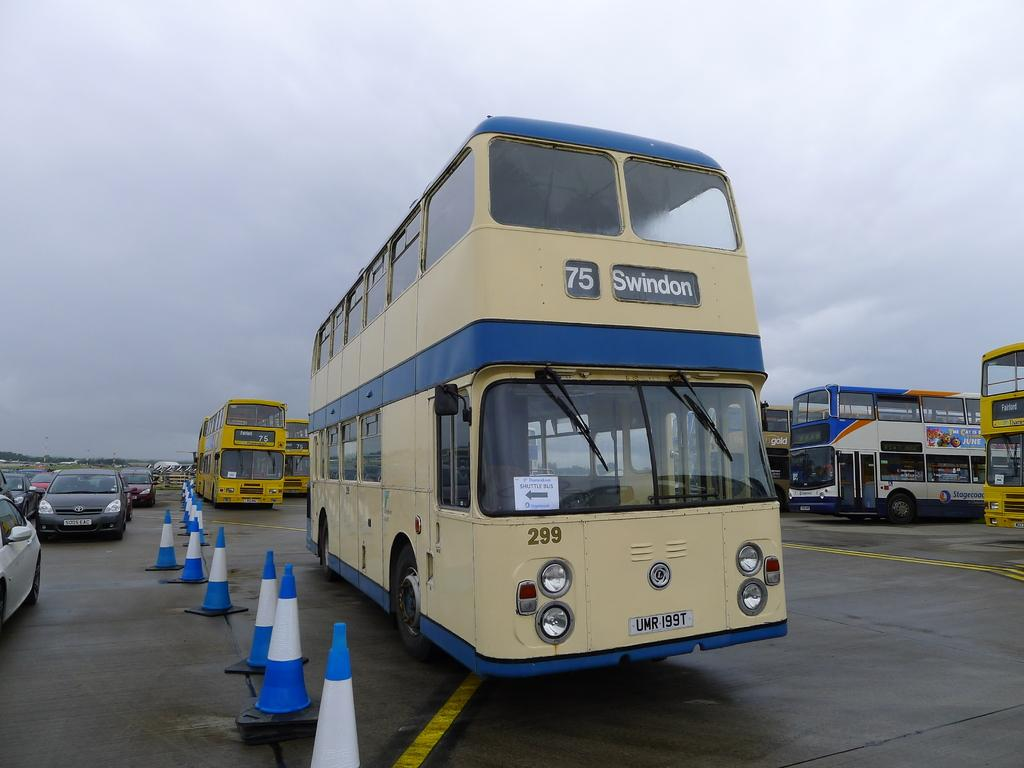What is happening on the road in the image? There are vehicles on the road in the image. Can you describe any specific details about the vehicles? Text is visible on some of the vehicles. What else is present beside the vehicles on the road? Barriers are present beside the vehicles. What is visible at the top of the image? The sky is visible at the top of the image. How many rabbits are sitting on the vehicles in the image? There are no rabbits present in the image; it features vehicles on the road with text and barriers beside them. 